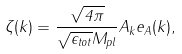<formula> <loc_0><loc_0><loc_500><loc_500>\zeta ( k ) = \frac { \sqrt { 4 \pi } } { \sqrt { \epsilon _ { t o t } } M _ { p l } } A _ { k } e _ { A } ( k ) ,</formula> 